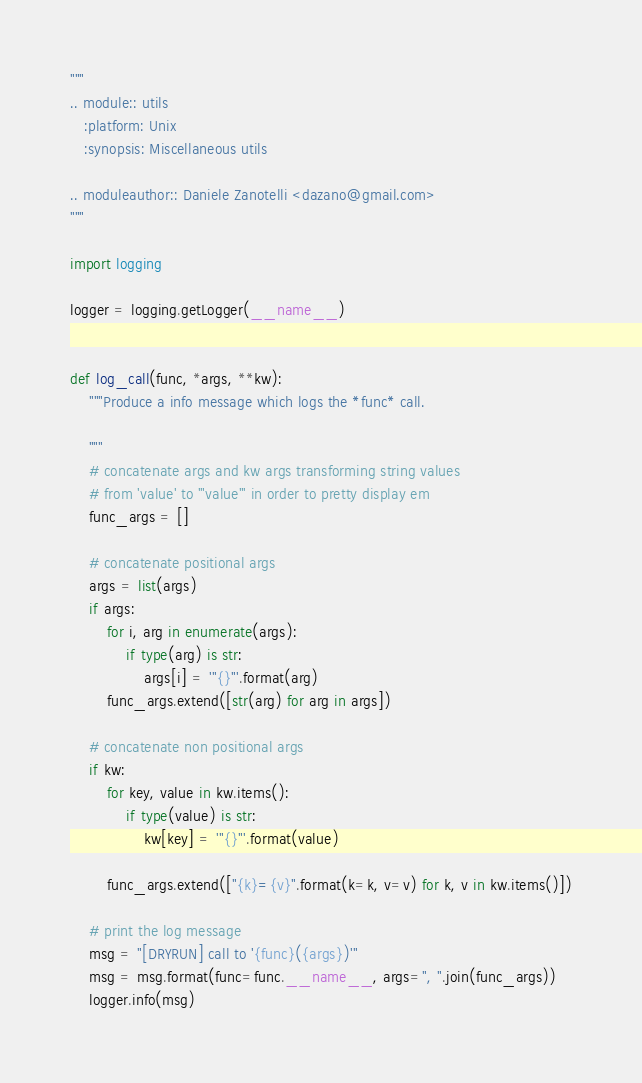Convert code to text. <code><loc_0><loc_0><loc_500><loc_500><_Python_>"""
.. module:: utils
   :platform: Unix
   :synopsis: Miscellaneous utils

.. moduleauthor:: Daniele Zanotelli <dazano@gmail.com>
"""

import logging

logger = logging.getLogger(__name__)


def log_call(func, *args, **kw):
    """Produce a info message which logs the *func* call.

    """
    # concatenate args and kw args transforming string values
    # from 'value' to '"value"' in order to pretty display em
    func_args = []

    # concatenate positional args
    args = list(args)
    if args:
        for i, arg in enumerate(args):
            if type(arg) is str:
                args[i] = '"{}"'.format(arg)
        func_args.extend([str(arg) for arg in args])

    # concatenate non positional args
    if kw:
        for key, value in kw.items():
            if type(value) is str:
                kw[key] = '"{}"'.format(value)

        func_args.extend(["{k}={v}".format(k=k, v=v) for k, v in kw.items()])

    # print the log message
    msg = "[DRYRUN] call to '{func}({args})'"
    msg = msg.format(func=func.__name__, args=", ".join(func_args))
    logger.info(msg)
</code> 